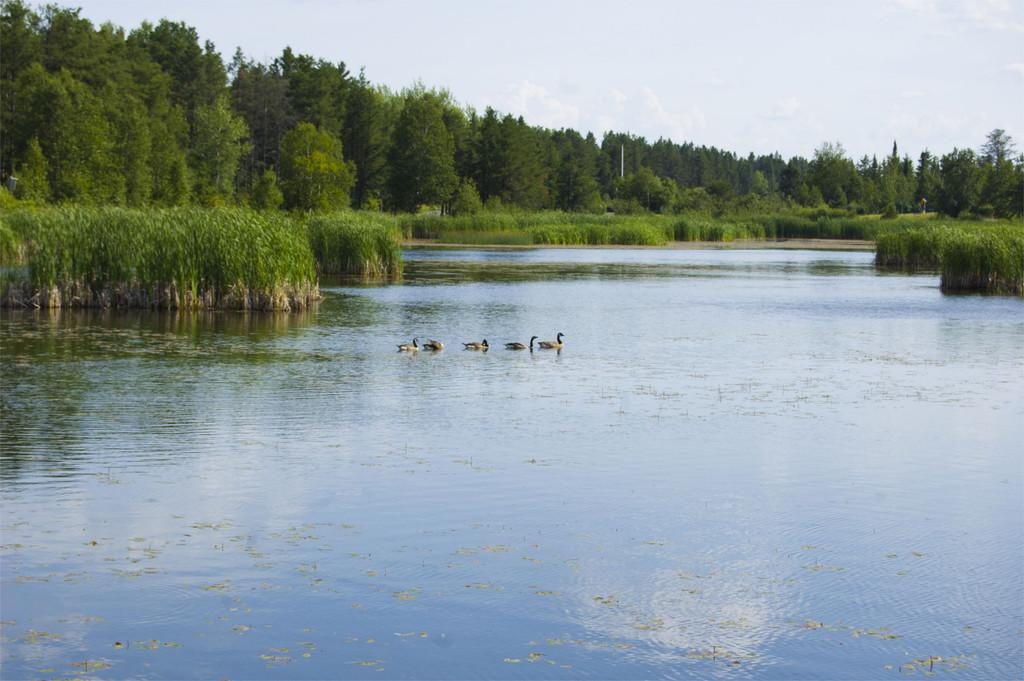What animals can be seen in the water in the image? There are ducks swimming in the water in the image. What else is present in the water besides the ducks? There are plants growing in the water. What can be seen in the background of the image? There are trees visible in the background. What is visible at the top of the image? The sky is clear and visible at the top of the image. Where is the mom and girl in the image? There is no mom or girl present in the image; it features ducks swimming in the water with plants growing in it, surrounded by trees in the background and a clear sky above. 